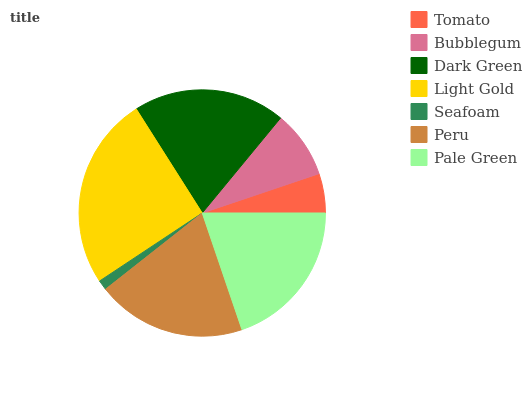Is Seafoam the minimum?
Answer yes or no. Yes. Is Light Gold the maximum?
Answer yes or no. Yes. Is Bubblegum the minimum?
Answer yes or no. No. Is Bubblegum the maximum?
Answer yes or no. No. Is Bubblegum greater than Tomato?
Answer yes or no. Yes. Is Tomato less than Bubblegum?
Answer yes or no. Yes. Is Tomato greater than Bubblegum?
Answer yes or no. No. Is Bubblegum less than Tomato?
Answer yes or no. No. Is Peru the high median?
Answer yes or no. Yes. Is Peru the low median?
Answer yes or no. Yes. Is Dark Green the high median?
Answer yes or no. No. Is Seafoam the low median?
Answer yes or no. No. 